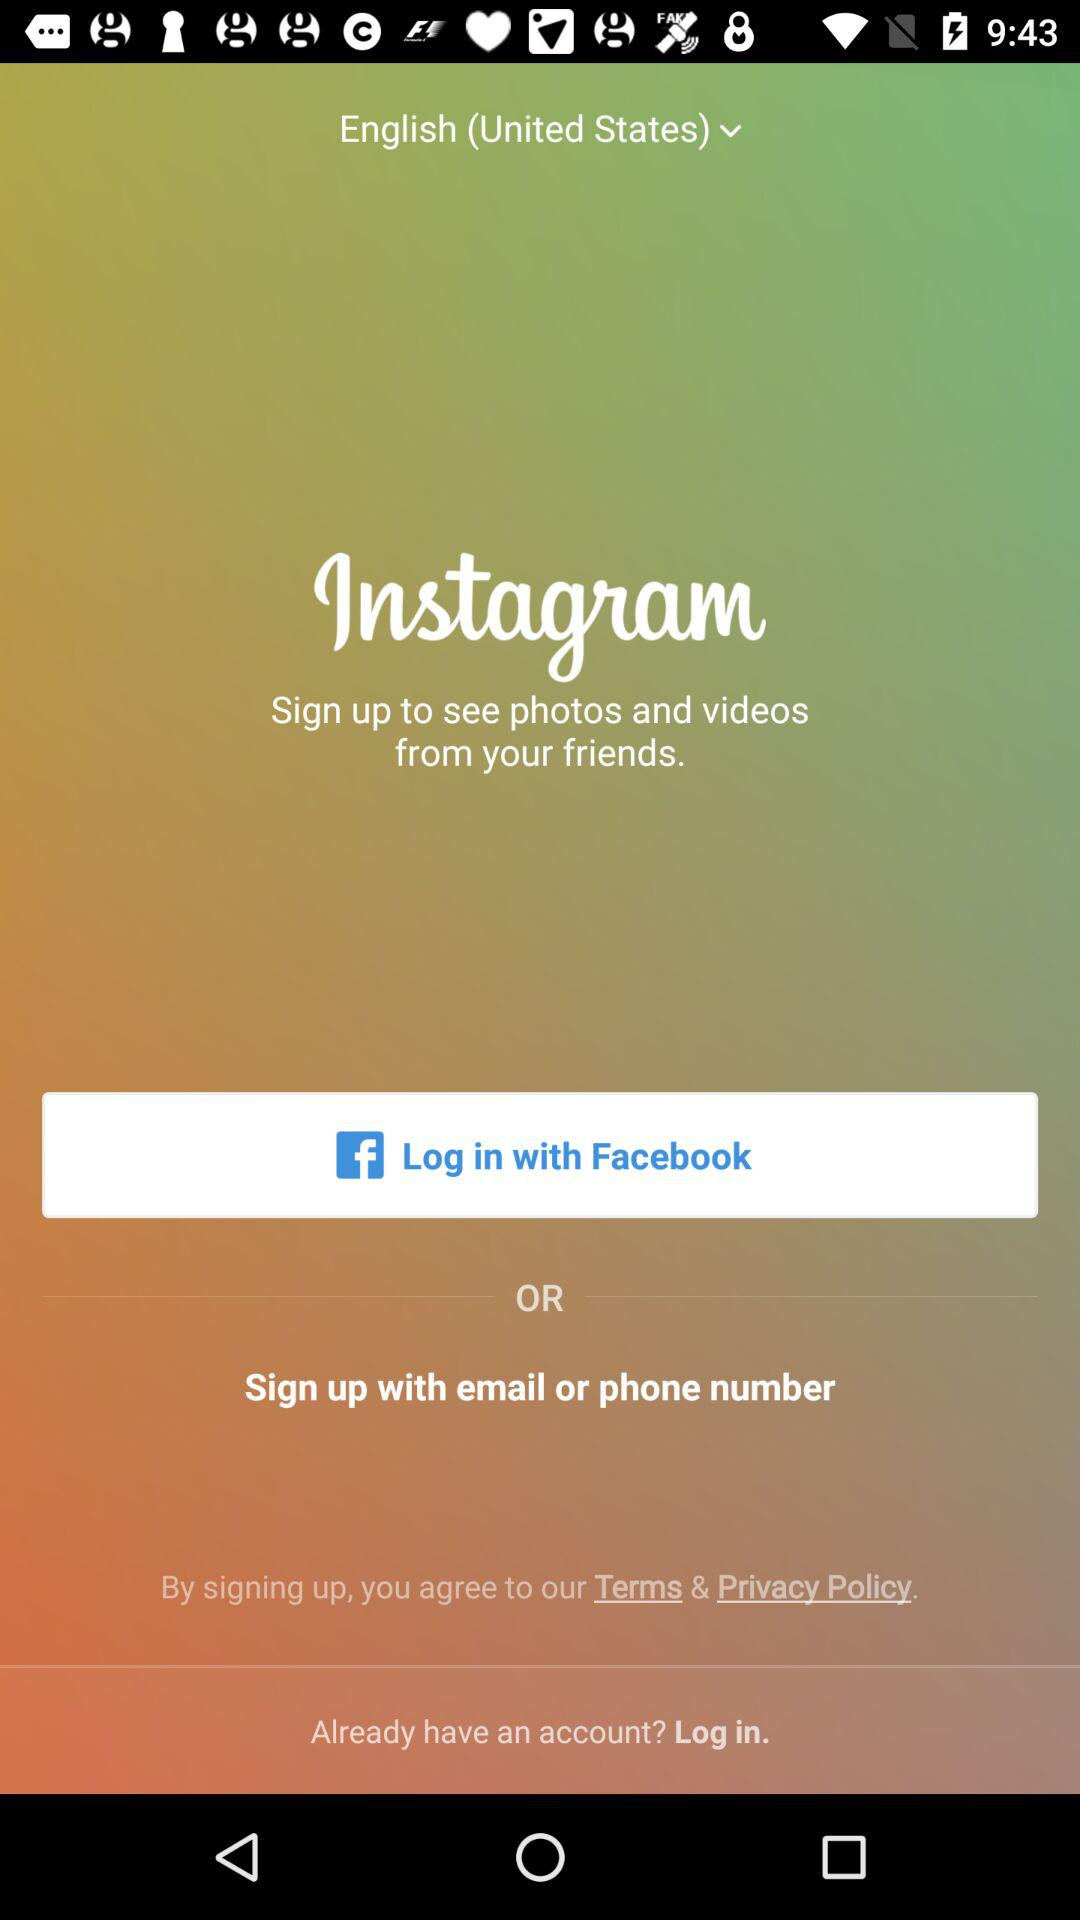What is the selected country?
When the provided information is insufficient, respond with <no answer>. <no answer> 